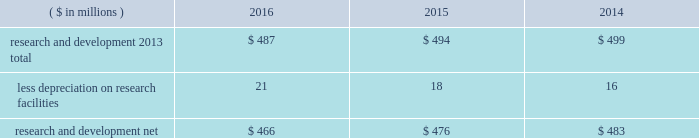Notes to the consolidated financial statements 40 2016 ppg annual report and form 10-k 1 .
Summary of significant accounting policies principles of consolidation the accompanying consolidated financial statements include the accounts of ppg industries , inc .
( 201cppg 201d or the 201ccompany 201d ) and all subsidiaries , both u.s .
And non-u.s. , that it controls .
Ppg owns more than 50% ( 50 % ) of the voting stock of most of the subsidiaries that it controls .
For those consolidated subsidiaries in which the company 2019s ownership is less than 100% ( 100 % ) , the outside shareholders 2019 interests are shown as noncontrolling interests .
Investments in companies in which ppg owns 20% ( 20 % ) to 50% ( 50 % ) of the voting stock and has the ability to exercise significant influence over operating and financial policies of the investee are accounted for using the equity method of accounting .
As a result , ppg 2019s share of the earnings or losses of such equity affiliates is included in the accompanying consolidated statement of income and ppg 2019s share of these companies 2019 shareholders 2019 equity is included in 201cinvestments 201d in the accompanying consolidated balance sheet .
Transactions between ppg and its subsidiaries are eliminated in consolidation .
Use of estimates in the preparation of financial statements the preparation of financial statements in conformity with u.s .
Generally accepted accounting principles requires management to make estimates and assumptions that affect the reported amounts of assets and liabilities and the disclosure of contingent assets and liabilities at the date of the financial statements , as well as the reported amounts of income and expenses during the reporting period .
Such estimates also include the fair value of assets acquired and liabilities assumed resulting from the allocation of the purchase price related to business combinations consummated .
Actual outcomes could differ from those estimates .
Revenue recognition the company recognizes revenue when the earnings process is complete .
Revenue is recognized by all operating segments when goods are shipped and title to inventory and risk of loss passes to the customer or when services have been rendered .
Shipping and handling costs amounts billed to customers for shipping and handling are reported in 201cnet sales 201d in the accompanying consolidated statement of income .
Shipping and handling costs incurred by the company for the delivery of goods to customers are included in 201ccost of sales , exclusive of depreciation and amortization 201d in the accompanying consolidated statement of income .
Selling , general and administrative costs amounts presented as 201cselling , general and administrative 201d in the accompanying consolidated statement of income are comprised of selling , customer service , distribution and advertising costs , as well as the costs of providing corporate- wide functional support in such areas as finance , law , human resources and planning .
Distribution costs pertain to the movement and storage of finished goods inventory at company- owned and leased warehouses and other distribution facilities .
Advertising costs advertising costs are expensed as incurred and totaled $ 322 million , $ 324 million and $ 297 million in 2016 , 2015 and 2014 , respectively .
Research and development research and development costs , which consist primarily of employee related costs , are charged to expense as incurred. .
Legal costs legal costs , primarily include costs associated with acquisition and divestiture transactions , general litigation , environmental regulation compliance , patent and trademark protection and other general corporate purposes , are charged to expense as incurred .
Foreign currency translation the functional currency of most significant non-u.s .
Operations is their local currency .
Assets and liabilities of those operations are translated into u.s .
Dollars using year-end exchange rates ; income and expenses are translated using the average exchange rates for the reporting period .
Unrealized foreign currency translation adjustments are deferred in accumulated other comprehensive loss , a separate component of shareholders 2019 equity .
Cash equivalents cash equivalents are highly liquid investments ( valued at cost , which approximates fair value ) acquired with an original maturity of three months or less .
Short-term investments short-term investments are highly liquid , high credit quality investments ( valued at cost plus accrued interest ) that have stated maturities of greater than three months to one year .
The purchases and sales of these investments are classified as investing activities in the consolidated statement of cash flows .
Marketable equity securities the company 2019s investment in marketable equity securities is recorded at fair market value and reported in 201cother current assets 201d and 201cinvestments 201d in the accompanying consolidated balance sheet with changes in fair market value recorded in income for those securities designated as trading securities and in other comprehensive income , net of tax , for those designated as available for sale securities. .
Are r&d expenses greater than advertising costs in 2016?\\n? 
Computations: (487 > 322)
Answer: yes. 